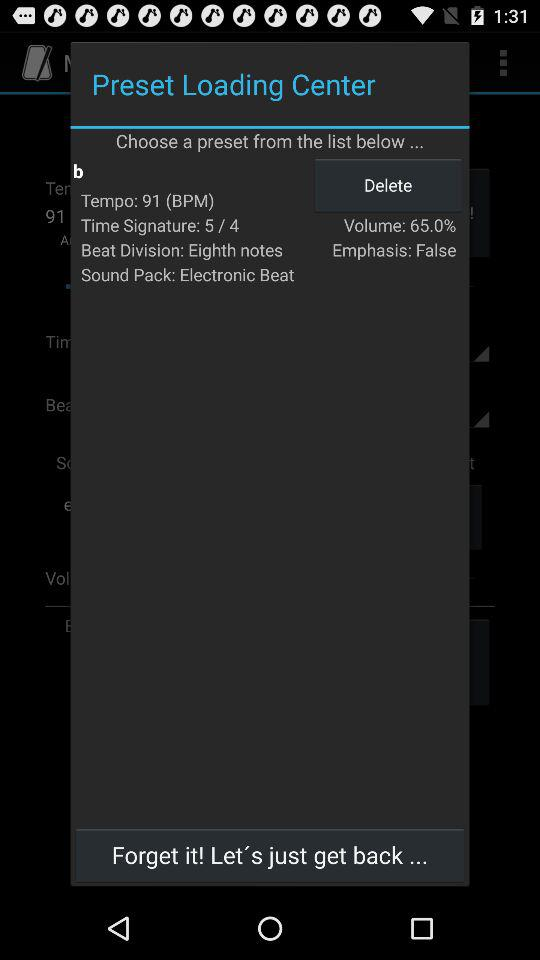What is the selected sound pack? The selected sound pack is Electronic Beat. 